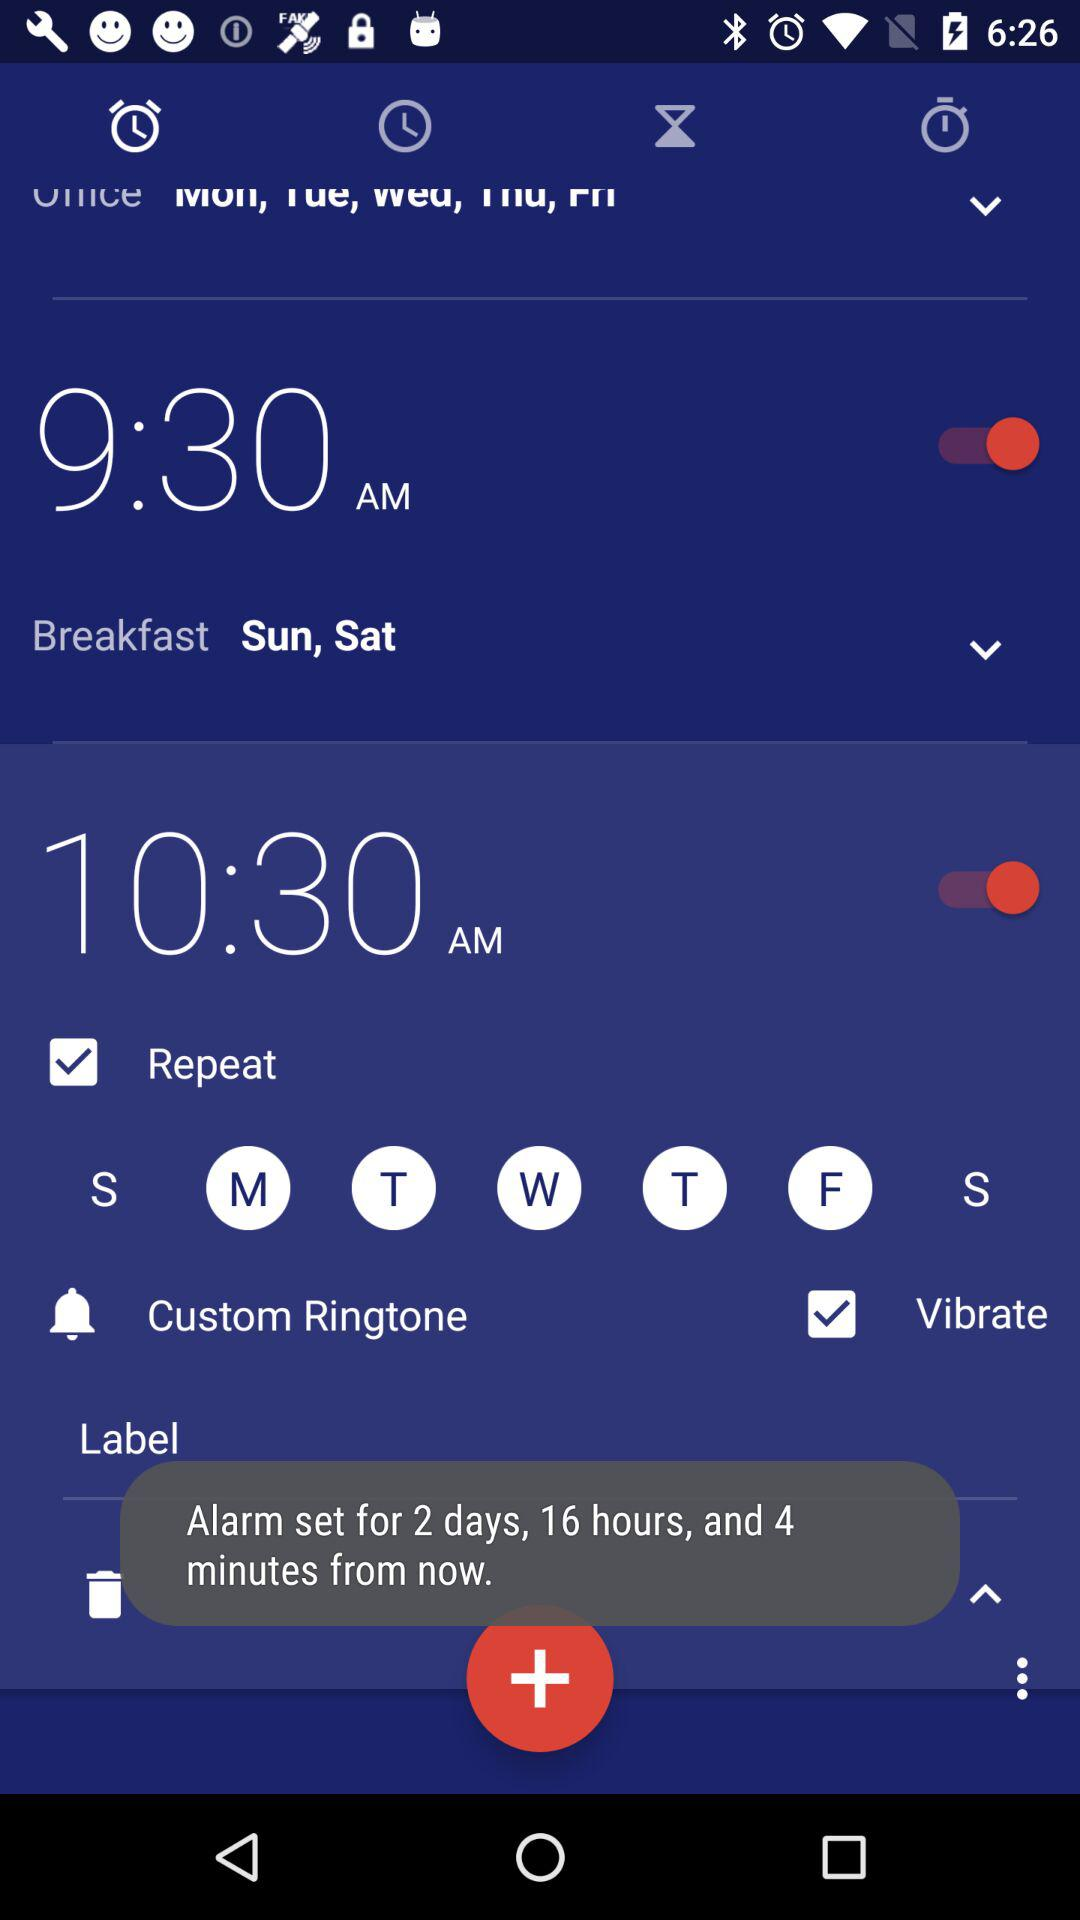On what days will the alarm repeat? The alarm will repeat on Monday, Tuesday, Wednesday, Thursday and Friday. 